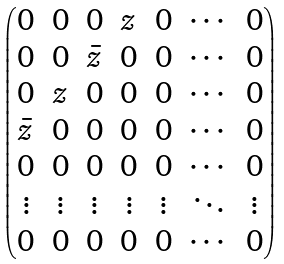Convert formula to latex. <formula><loc_0><loc_0><loc_500><loc_500>\begin{pmatrix} 0 & 0 & 0 & z & 0 & \cdots & 0 \\ 0 & 0 & \bar { z } & 0 & 0 & \cdots & 0 \\ 0 & z & 0 & 0 & 0 & \cdots & 0 \\ \bar { z } & 0 & 0 & 0 & 0 & \cdots & 0 \\ 0 & 0 & 0 & 0 & 0 & \cdots & 0 \\ \vdots & \vdots & \vdots & \vdots & \vdots & \ddots & \vdots \\ 0 & 0 & 0 & 0 & 0 & \cdots & 0 \\ \end{pmatrix}</formula> 